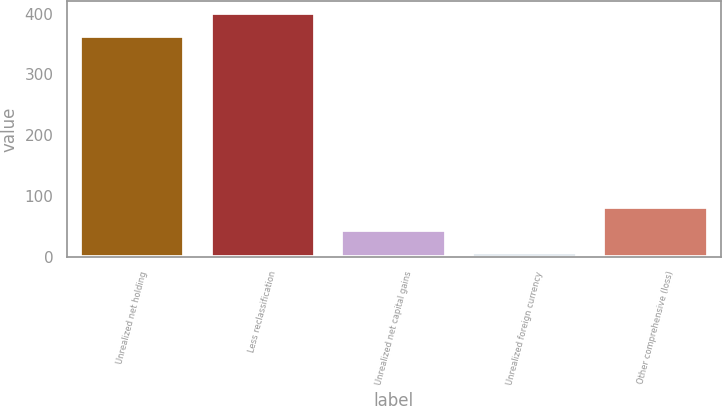Convert chart. <chart><loc_0><loc_0><loc_500><loc_500><bar_chart><fcel>Unrealized net holding<fcel>Less reclassification<fcel>Unrealized net capital gains<fcel>Unrealized foreign currency<fcel>Other comprehensive (loss)<nl><fcel>363<fcel>401.2<fcel>44.2<fcel>6<fcel>82.4<nl></chart> 